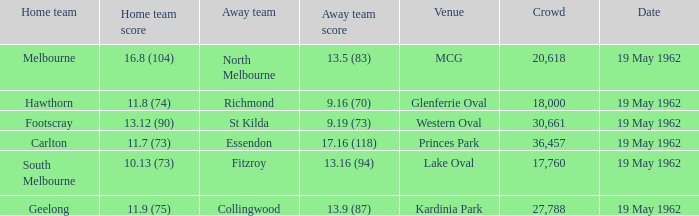What is the home team's score at mcg? 16.8 (104). 